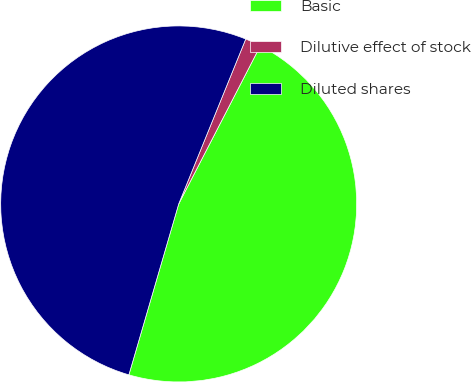<chart> <loc_0><loc_0><loc_500><loc_500><pie_chart><fcel>Basic<fcel>Dilutive effect of stock<fcel>Diluted shares<nl><fcel>46.93%<fcel>1.44%<fcel>51.63%<nl></chart> 